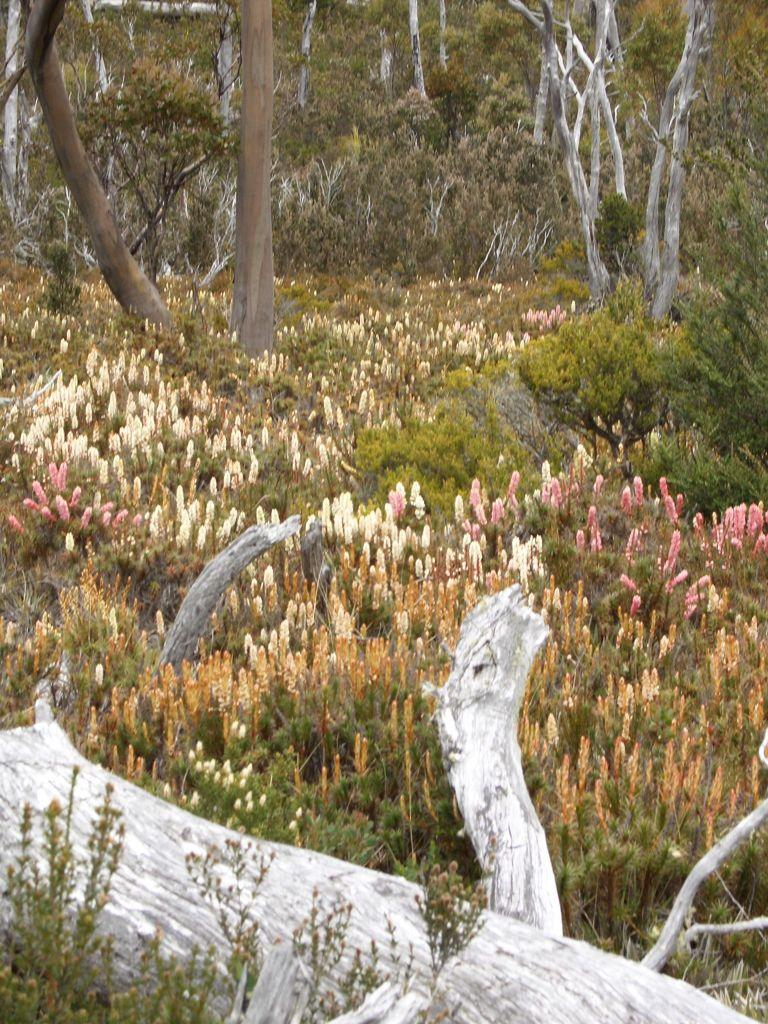What type of view is shown in the image? The image is an outside view. What kind of trees can be seen in the image? There are dried trees and green trees in the image. Are there any plants with flowers in the image? Yes, there are plants with flowers in the image. What is the condition of the wood at the bottom of the image? The wood at the bottom of the image is broken. How many sheep are grazing in the image? There are no sheep present in the image. What type of work is the carpenter doing in the image? There is no carpenter present in the image. What kind of military vehicle can be seen in the image? There is no military vehicle, such as a tank, present in the image. 